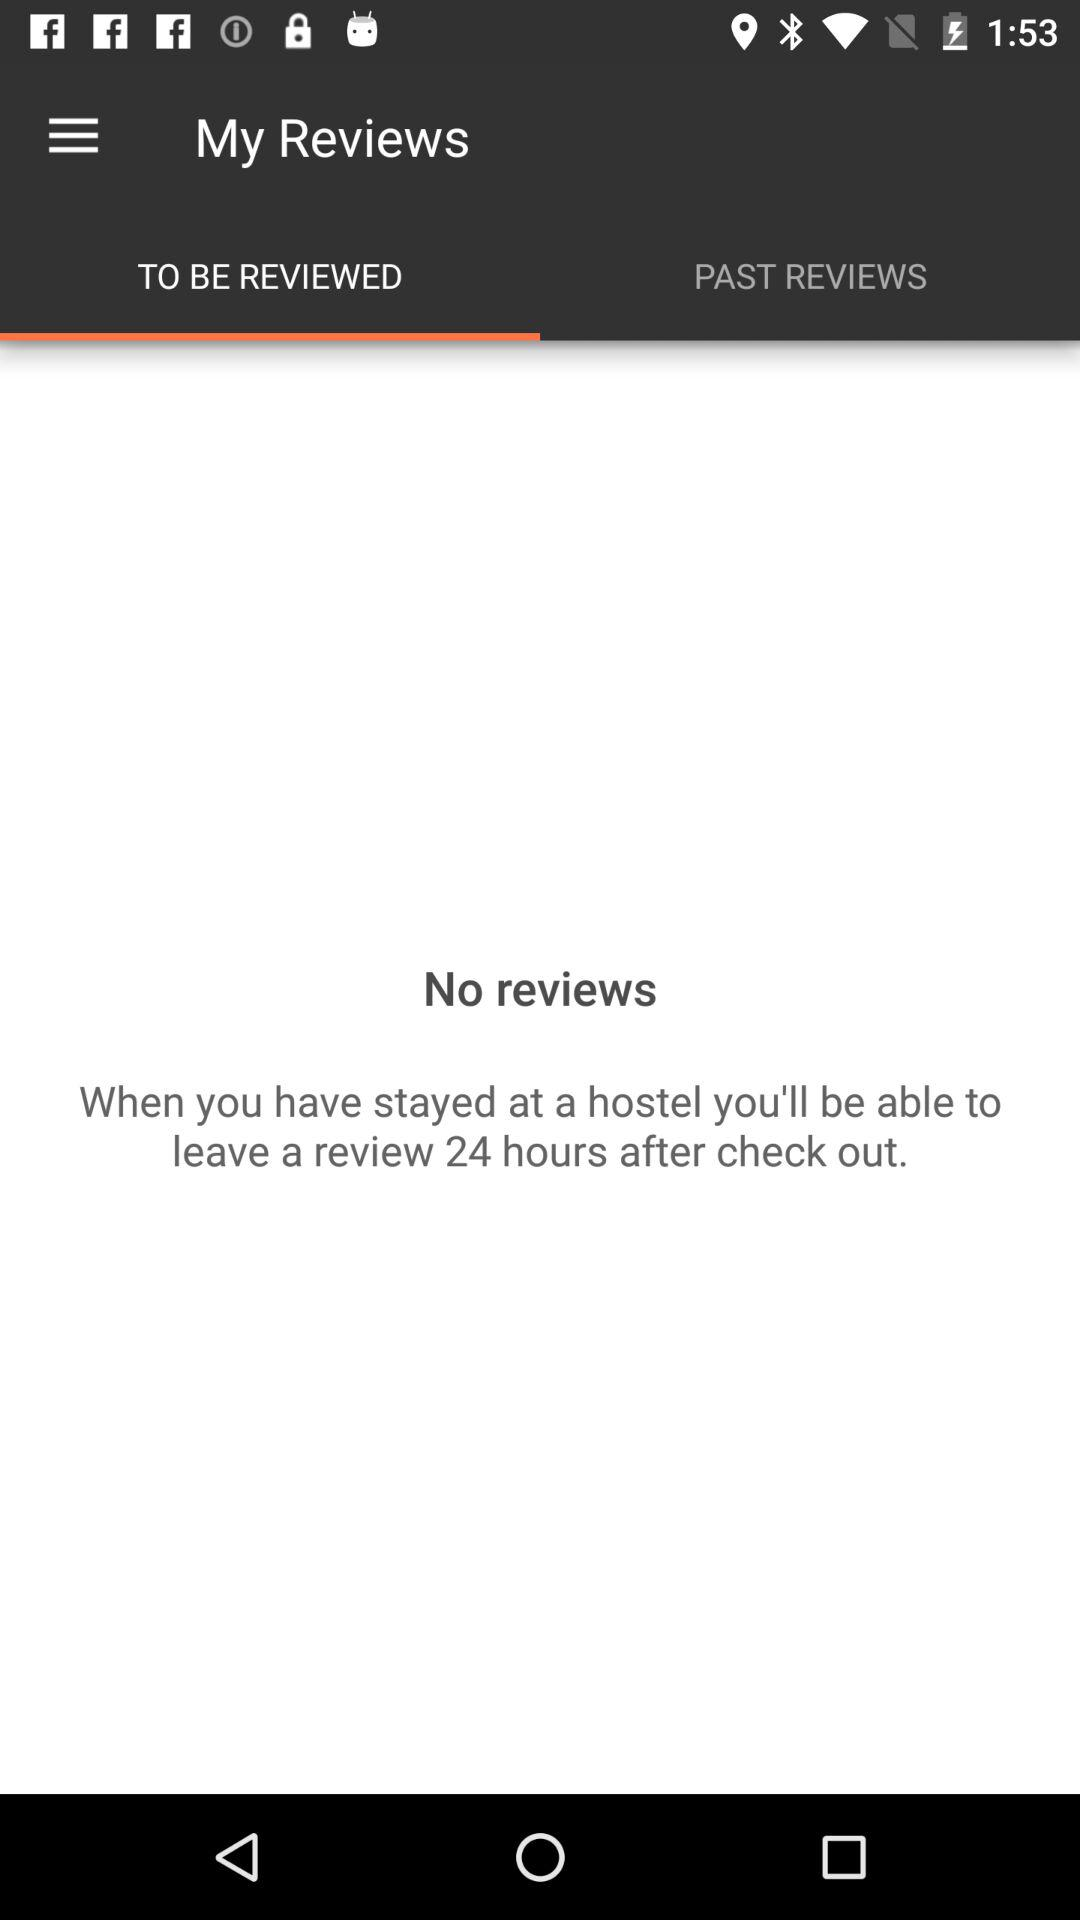Are there any reviews? There are no reviews. 